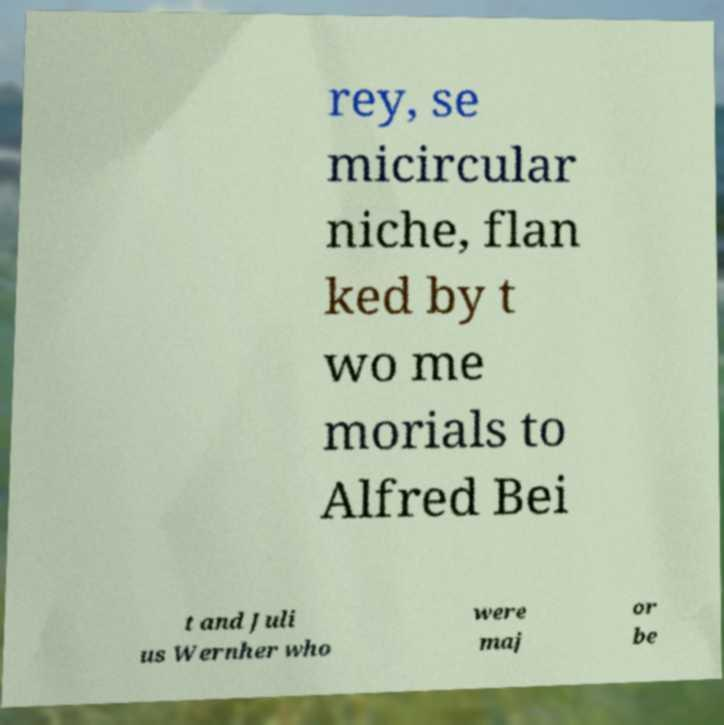I need the written content from this picture converted into text. Can you do that? rey, se micircular niche, flan ked by t wo me morials to Alfred Bei t and Juli us Wernher who were maj or be 